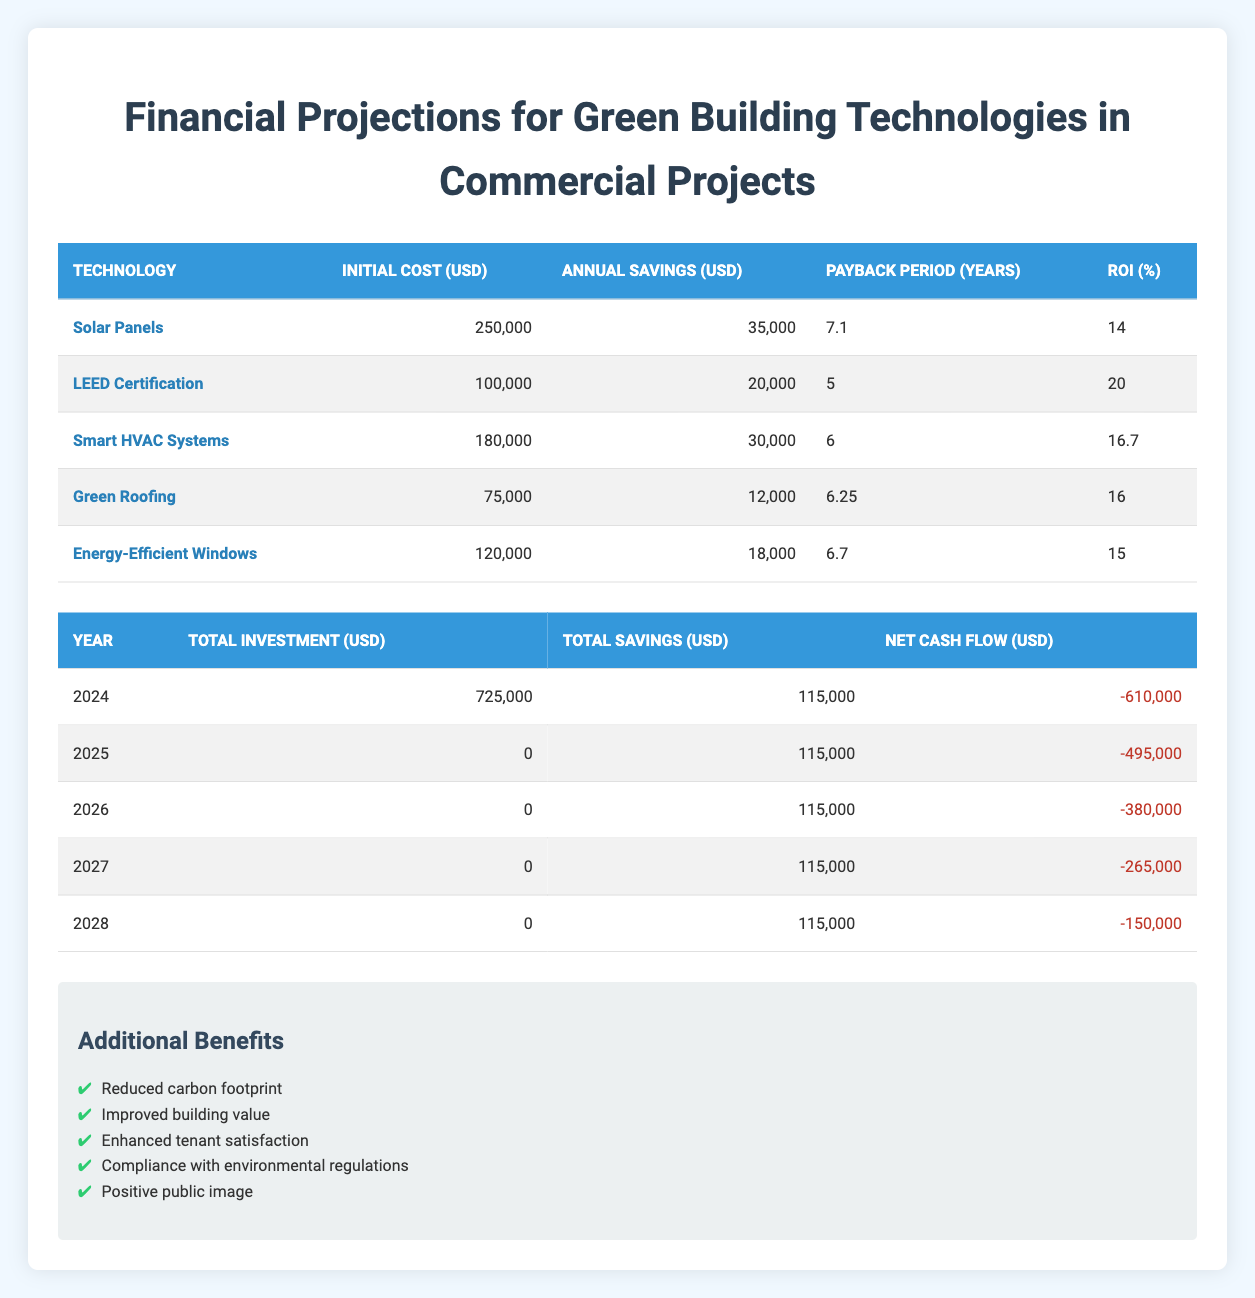What is the initial cost of Solar Panels? According to the table, the initial cost of Solar Panels is listed under the "Initial Cost (USD)" column for that technology. The value stated is 250,000.
Answer: 250,000 What is the annual savings from LEED Certification? The table shows that the annual savings from LEED Certification can be found in the "Annual Savings (USD)" column for that technology. The value stated is 20,000.
Answer: 20,000 What is the average payback period for all technologies? To calculate the average payback period, sum the payback periods of all technologies (7.1 + 5 + 6 + 6.25 + 6.7 = 31.05), then divide that sum by the number of technologies (31.05 / 5 = 6.21).
Answer: 6.21 In which year is the net cash flow the least negative? By examining the "Net Cash Flow (USD)" column in the annual projections table, the least negative value occurs in 2028 (–150,000).
Answer: 2028 Is it true that Energy-Efficient Windows have a higher initial cost than Green Roofing? Comparing the "Initial Cost (USD)" values in the table reveals that Energy-Efficient Windows cost 120,000, while Green Roofing costs 75,000. Since 120,000 is greater than 75,000, the statement is true.
Answer: Yes What is the total amount of investment made by 2026? The total amount of investment by 2026 is the cumulative investment values for 2024, 2025, and 2026. Since there was an investment of 725,000 in 2024 and no additional investment in the following years, the total is 725,000.
Answer: 725,000 Which technology has the highest ROI? The Return on Investment (ROI) values for the technologies can be found in the corresponding column. LEED Certification has the highest ROI at 20.
Answer: LEED Certification Was there any investment made in 2025? The table under total investment shows 0 for the year 2025, indicating that no investment was made that year. Therefore, this statement is false.
Answer: No What is the difference in annual savings between Smart HVAC Systems and Energy-Efficient Windows? The annual savings for Smart HVAC Systems is 30,000 and for Energy-Efficient Windows is 18,000. The difference is calculated as 30,000 - 18,000 = 12,000.
Answer: 12,000 